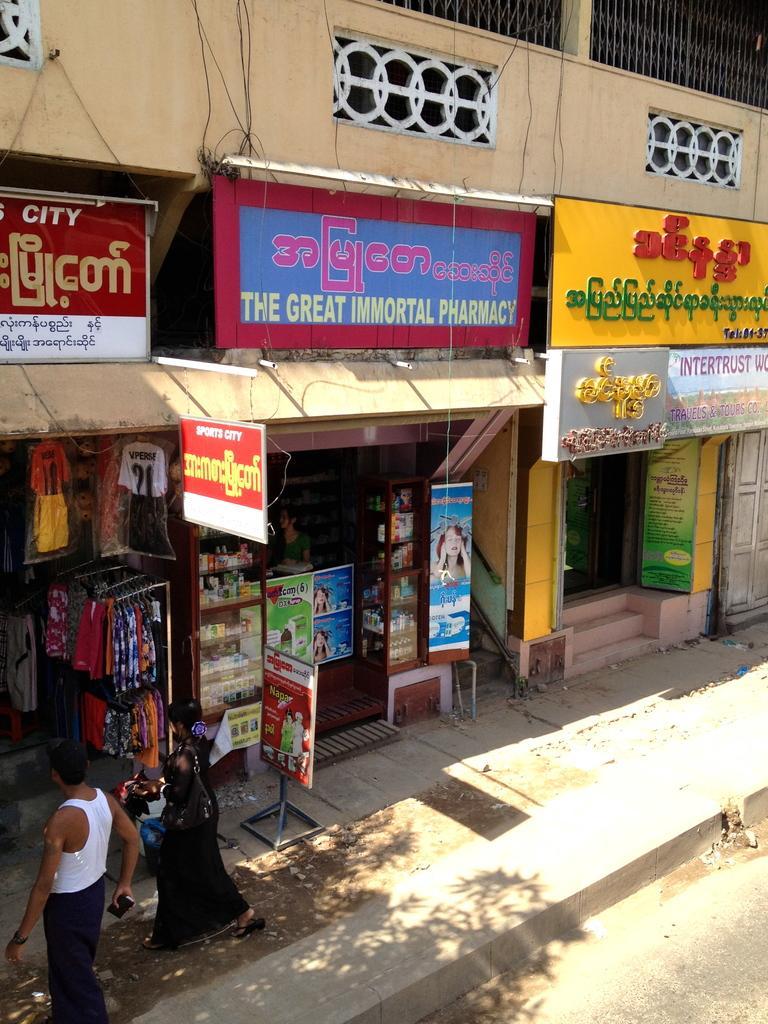Could you give a brief overview of what you see in this image? This picture consists of building and under the building there is a shop and there are two persons walking in front of the building and I can see there are hoarding boards visible on the building wall. 